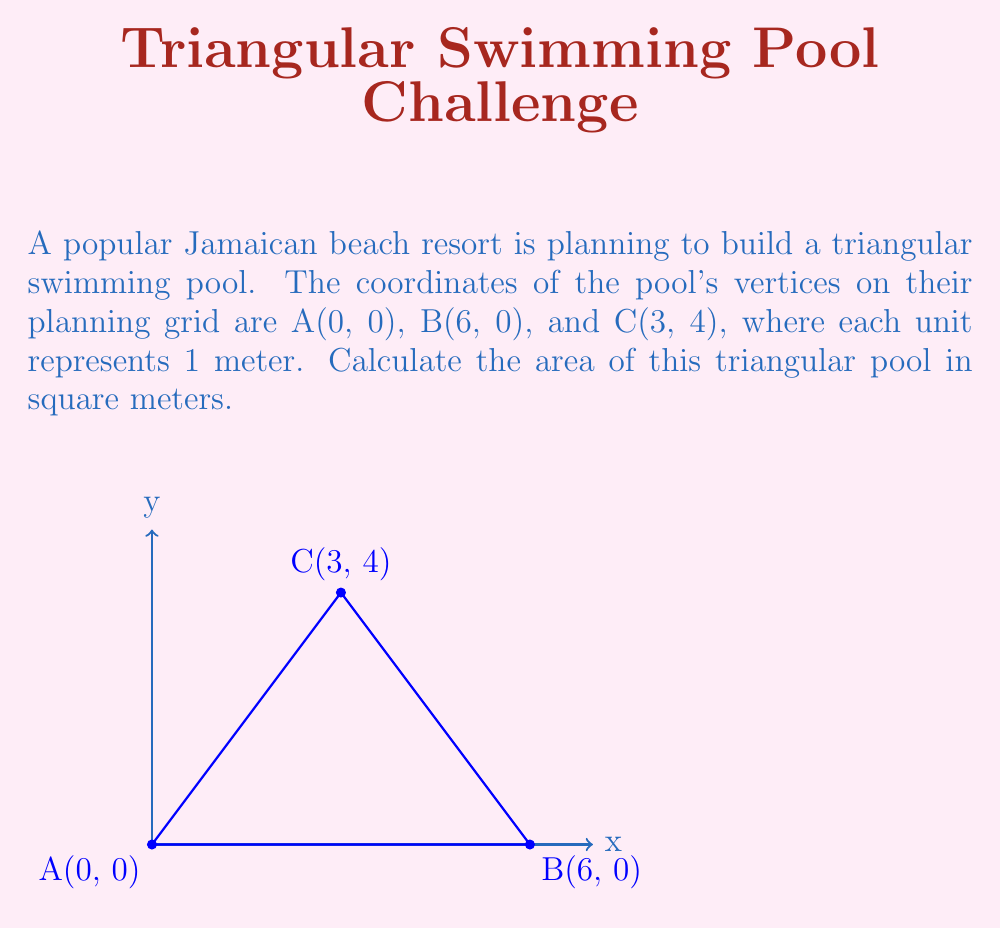Provide a solution to this math problem. To calculate the area of a triangle using the coordinates of its vertices, we can use the formula:

$$ \text{Area} = \frac{1}{2}|x_1(y_2 - y_3) + x_2(y_3 - y_1) + x_3(y_1 - y_2)| $$

Where $(x_1, y_1)$, $(x_2, y_2)$, and $(x_3, y_3)$ are the coordinates of the three vertices.

Let's substitute the given coordinates:
A(0, 0), B(6, 0), and C(3, 4)

$x_1 = 0$, $y_1 = 0$
$x_2 = 6$, $y_2 = 0$
$x_3 = 3$, $y_3 = 4$

Now, let's plug these values into the formula:

$$ \text{Area} = \frac{1}{2}|0(0 - 4) + 6(4 - 0) + 3(0 - 0)| $$

Simplifying:
$$ \text{Area} = \frac{1}{2}|0 + 24 + 0| $$
$$ \text{Area} = \frac{1}{2}|24| $$
$$ \text{Area} = \frac{1}{2} \cdot 24 $$
$$ \text{Area} = 12 $$

Therefore, the area of the triangular pool is 12 square meters.
Answer: 12 m² 